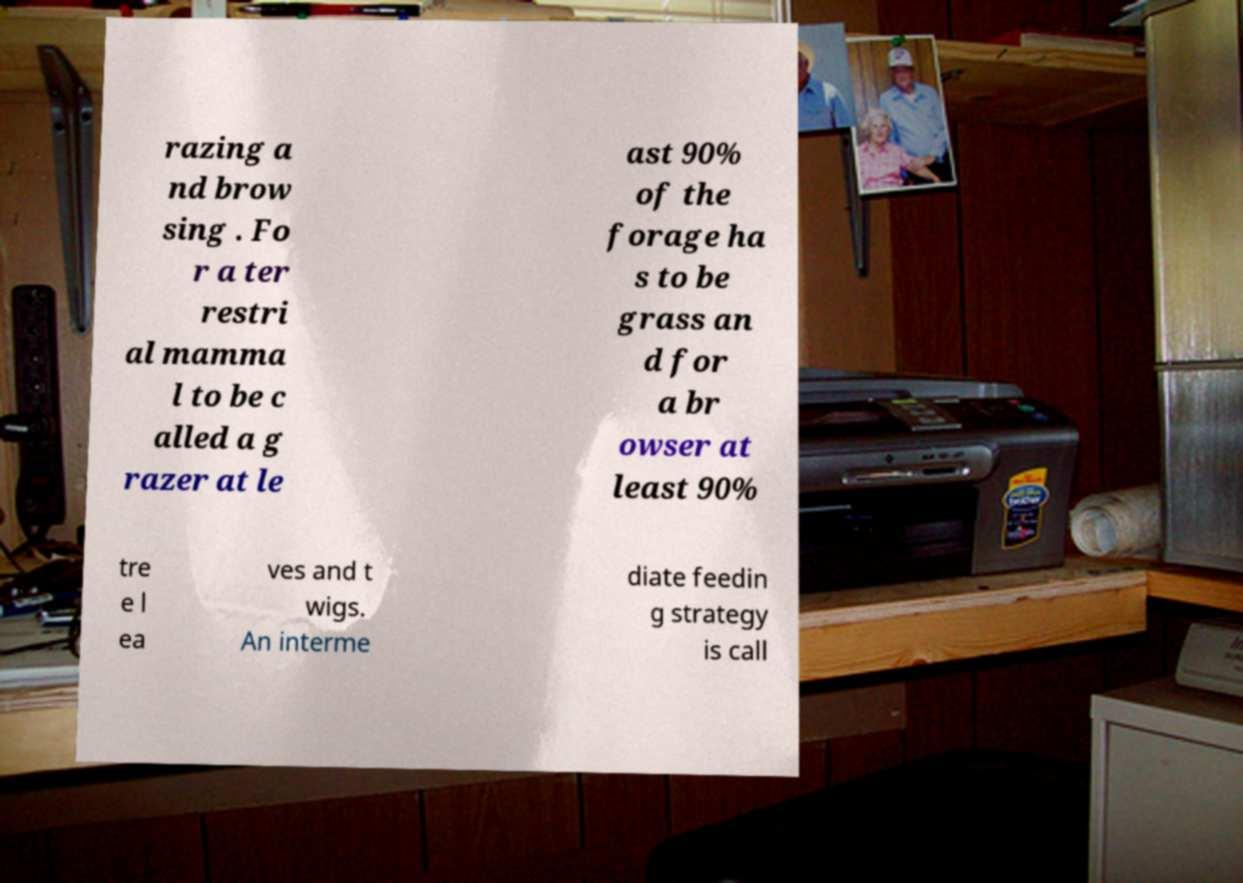What messages or text are displayed in this image? I need them in a readable, typed format. razing a nd brow sing . Fo r a ter restri al mamma l to be c alled a g razer at le ast 90% of the forage ha s to be grass an d for a br owser at least 90% tre e l ea ves and t wigs. An interme diate feedin g strategy is call 